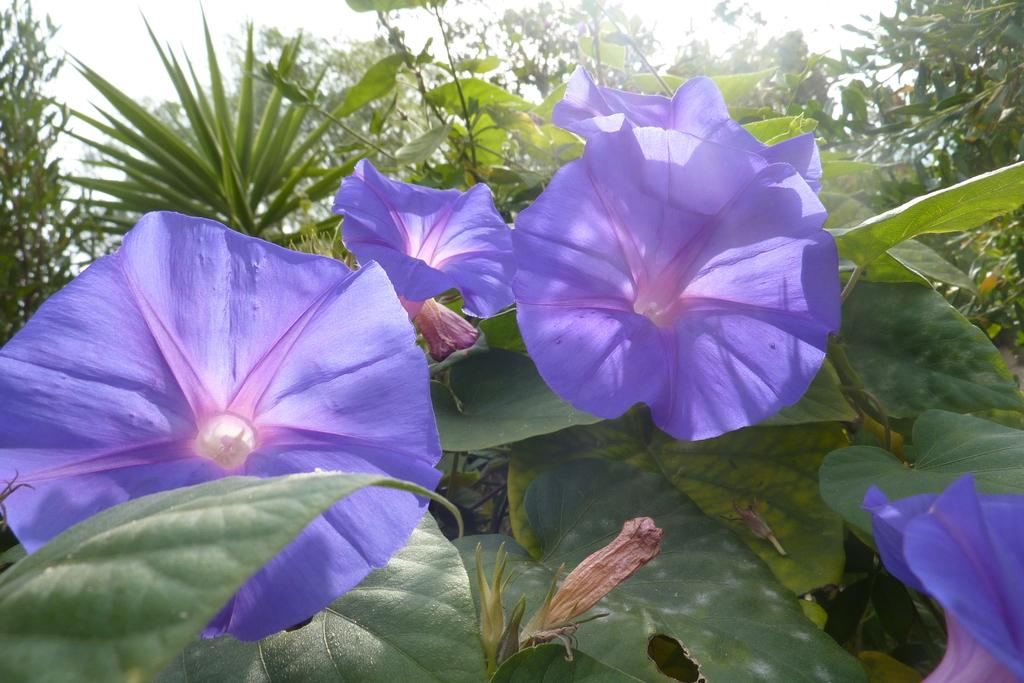What type of vegetation can be seen in the image? There are flowers, leaves, plants, and trees in the image. What part of the natural environment is visible in the image? The sky is visible in the image. Can you describe the vegetation in more detail? The image contains flowers, leaves, and plants, as well as trees. Who is the daughter in the image, and what is she doing? There is no daughter present in the image; it features vegetation and the sky. 